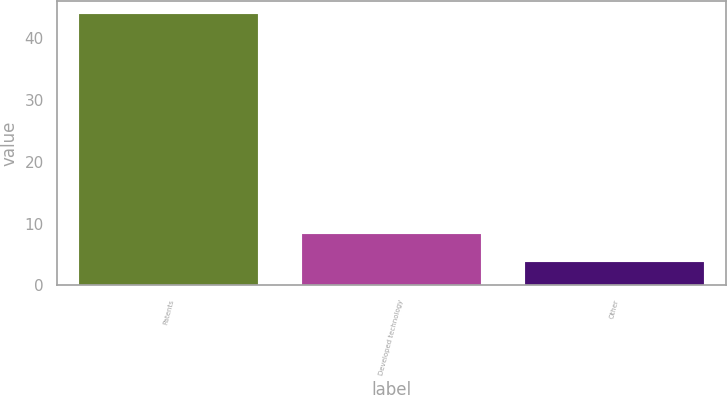Convert chart. <chart><loc_0><loc_0><loc_500><loc_500><bar_chart><fcel>Patents<fcel>Developed technology<fcel>Other<nl><fcel>43.9<fcel>8.3<fcel>3.8<nl></chart> 